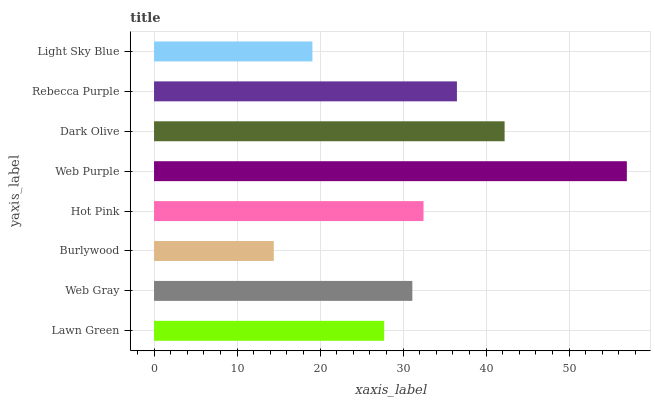Is Burlywood the minimum?
Answer yes or no. Yes. Is Web Purple the maximum?
Answer yes or no. Yes. Is Web Gray the minimum?
Answer yes or no. No. Is Web Gray the maximum?
Answer yes or no. No. Is Web Gray greater than Lawn Green?
Answer yes or no. Yes. Is Lawn Green less than Web Gray?
Answer yes or no. Yes. Is Lawn Green greater than Web Gray?
Answer yes or no. No. Is Web Gray less than Lawn Green?
Answer yes or no. No. Is Hot Pink the high median?
Answer yes or no. Yes. Is Web Gray the low median?
Answer yes or no. Yes. Is Light Sky Blue the high median?
Answer yes or no. No. Is Light Sky Blue the low median?
Answer yes or no. No. 